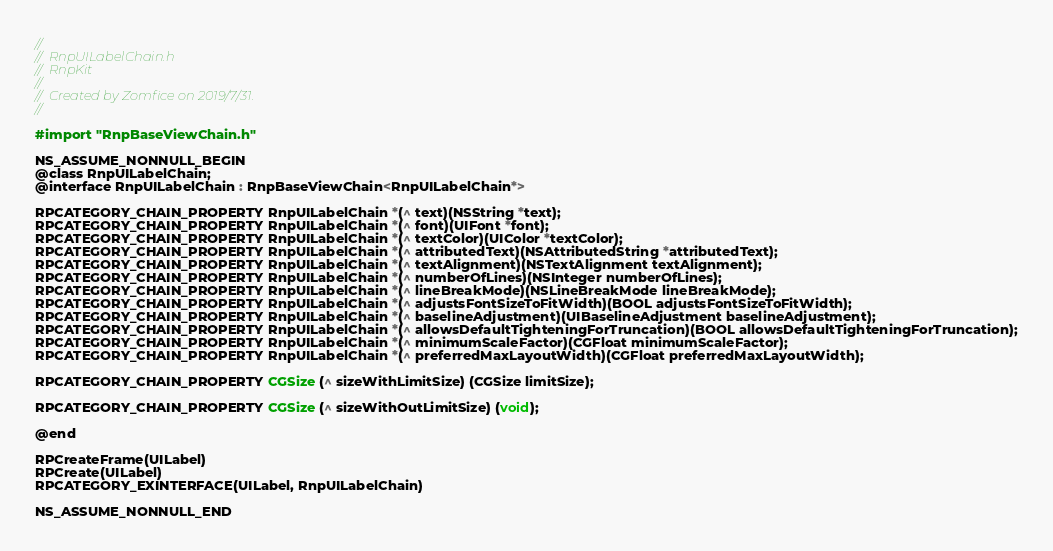Convert code to text. <code><loc_0><loc_0><loc_500><loc_500><_C_>//
//  RnpUILabelChain.h
//  RnpKit
//
//  Created by Zomfice on 2019/7/31.
//

#import "RnpBaseViewChain.h"

NS_ASSUME_NONNULL_BEGIN
@class RnpUILabelChain;
@interface RnpUILabelChain : RnpBaseViewChain<RnpUILabelChain*>

RPCATEGORY_CHAIN_PROPERTY RnpUILabelChain *(^ text)(NSString *text);
RPCATEGORY_CHAIN_PROPERTY RnpUILabelChain *(^ font)(UIFont *font);
RPCATEGORY_CHAIN_PROPERTY RnpUILabelChain *(^ textColor)(UIColor *textColor);
RPCATEGORY_CHAIN_PROPERTY RnpUILabelChain *(^ attributedText)(NSAttributedString *attributedText);
RPCATEGORY_CHAIN_PROPERTY RnpUILabelChain *(^ textAlignment)(NSTextAlignment textAlignment);
RPCATEGORY_CHAIN_PROPERTY RnpUILabelChain *(^ numberOfLines)(NSInteger numberOfLines);
RPCATEGORY_CHAIN_PROPERTY RnpUILabelChain *(^ lineBreakMode)(NSLineBreakMode lineBreakMode);
RPCATEGORY_CHAIN_PROPERTY RnpUILabelChain *(^ adjustsFontSizeToFitWidth)(BOOL adjustsFontSizeToFitWidth);
RPCATEGORY_CHAIN_PROPERTY RnpUILabelChain *(^ baselineAdjustment)(UIBaselineAdjustment baselineAdjustment);
RPCATEGORY_CHAIN_PROPERTY RnpUILabelChain *(^ allowsDefaultTighteningForTruncation)(BOOL allowsDefaultTighteningForTruncation);
RPCATEGORY_CHAIN_PROPERTY RnpUILabelChain *(^ minimumScaleFactor)(CGFloat minimumScaleFactor);
RPCATEGORY_CHAIN_PROPERTY RnpUILabelChain *(^ preferredMaxLayoutWidth)(CGFloat preferredMaxLayoutWidth);

RPCATEGORY_CHAIN_PROPERTY CGSize (^ sizeWithLimitSize) (CGSize limitSize);

RPCATEGORY_CHAIN_PROPERTY CGSize (^ sizeWithOutLimitSize) (void);

@end

RPCreateFrame(UILabel)
RPCreate(UILabel)
RPCATEGORY_EXINTERFACE(UILabel, RnpUILabelChain)

NS_ASSUME_NONNULL_END
</code> 